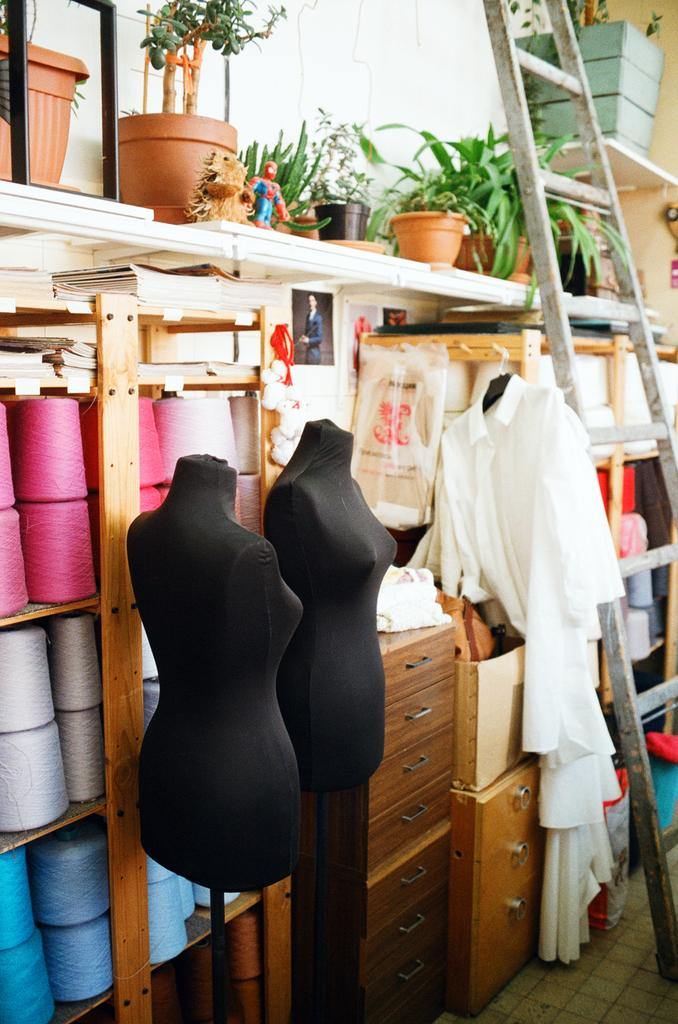What type of items are featured in the image? There are colorful rolls in the image. Where are the rolls located? The rolls are on a shelf. What else can be seen in the image besides the rolls? There are potted plants and clothes visible in the image. Reasoning: Let's think step by step by step in order to produce the conversation. We start by identifying the main subject in the image, which is the colorful rolls. Then, we expand the conversation to include other items that are also visible, such as the shelf, potted plants, and clothes. Each question is designed to elicit a specific detail about the image that is known from the provided facts}. We avoid yes/no questions and ensure that the language is simple and clear}. Absurd Question/Answer: How many friends are present in the image? There is no indication of friends in the image; it features colorful rolls, a shelf, potted plants, and clothes. Can you measure the height of the stranger in the image? There is no stranger present in the image; it features colorful rolls, a shelf, potted plants, and clothes. How many friends are present in the image? There is no indication of friends in the image; it features colorful rolls, a shelf, potted plants, and clothes. Can you measure the height of the stranger in the image? There is no stranger present in the image; it features colorful rolls, a shelf, potted plants, and clothes. 